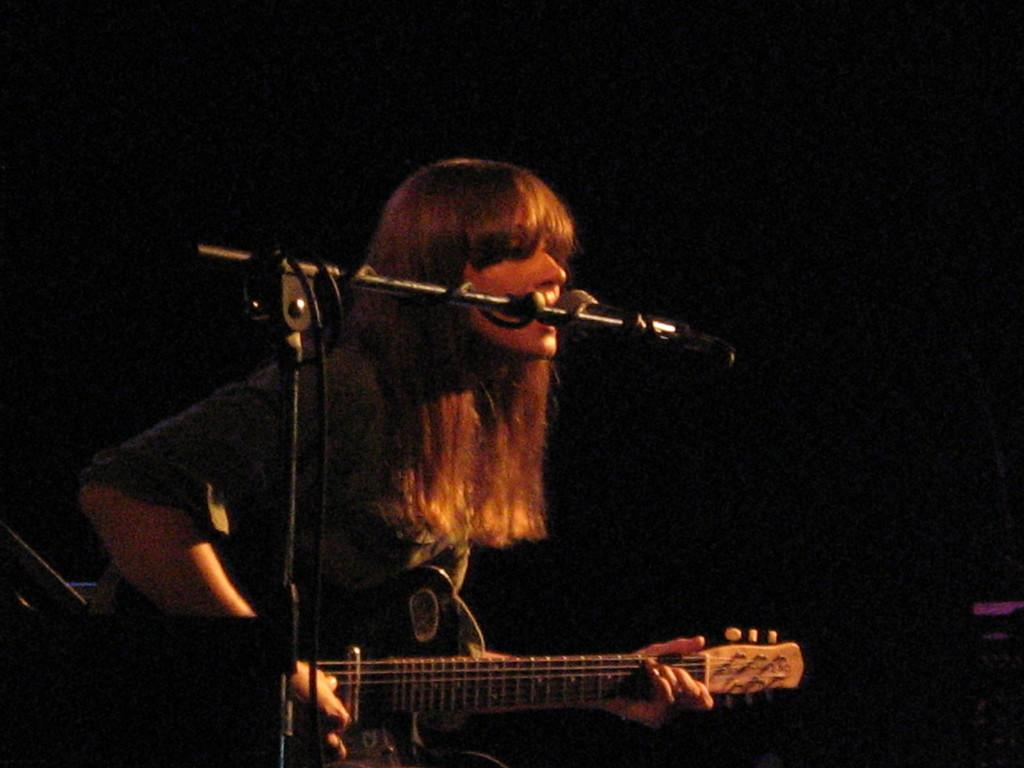What type of event is depicted in the image? The image is from a musical concert. Can you describe the person performing in the image? There is a woman in the image, and she is singing. What instrument is the woman playing? The woman is playing a guitar. How is the woman's voice being amplified in the image? The woman has a microphone in front of her. What level of the building is the woman performing on in the image? The image does not provide information about the building or the level the woman is performing on. 